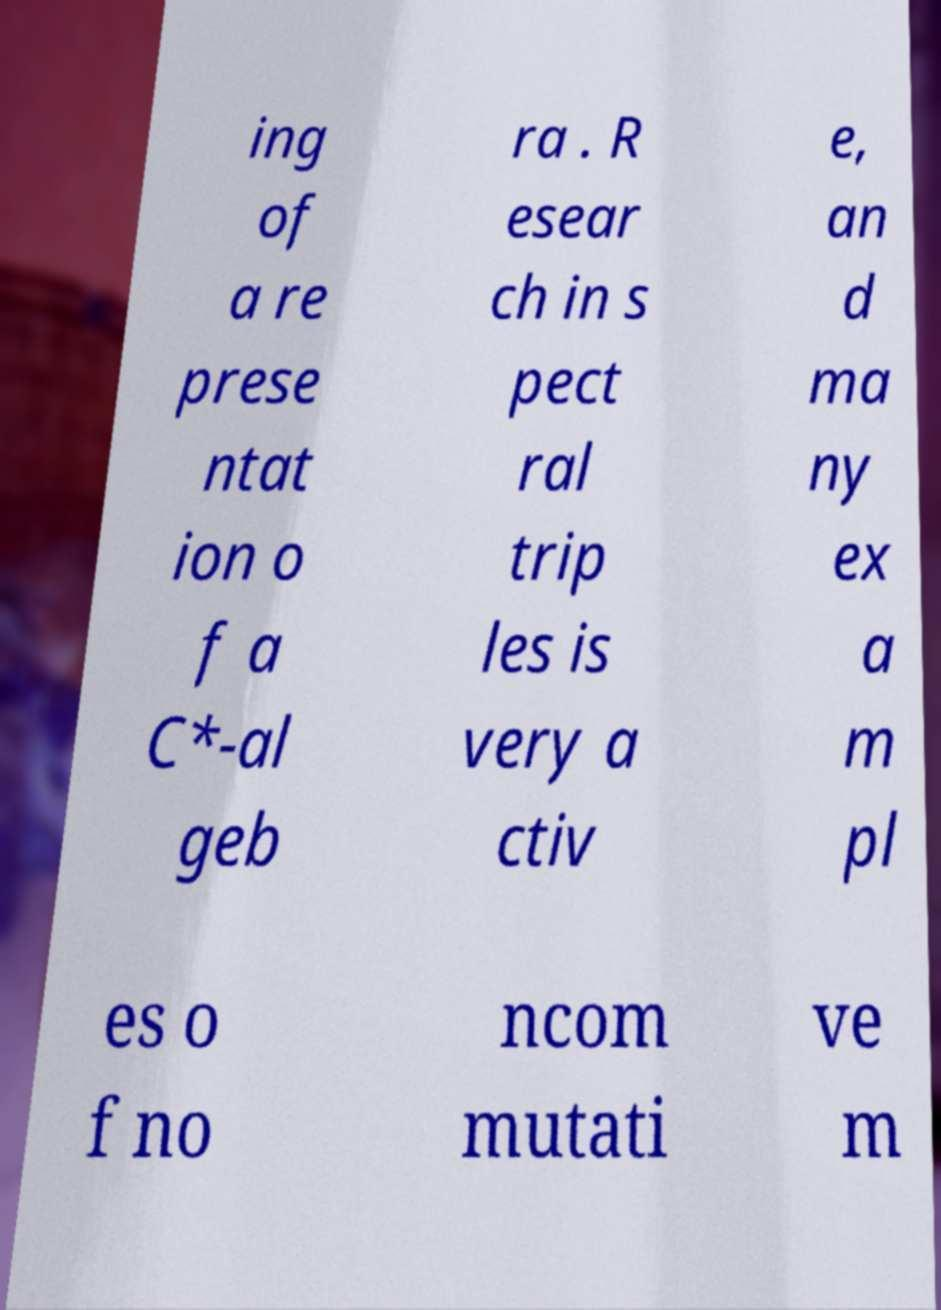For documentation purposes, I need the text within this image transcribed. Could you provide that? ing of a re prese ntat ion o f a C*-al geb ra . R esear ch in s pect ral trip les is very a ctiv e, an d ma ny ex a m pl es o f no ncom mutati ve m 